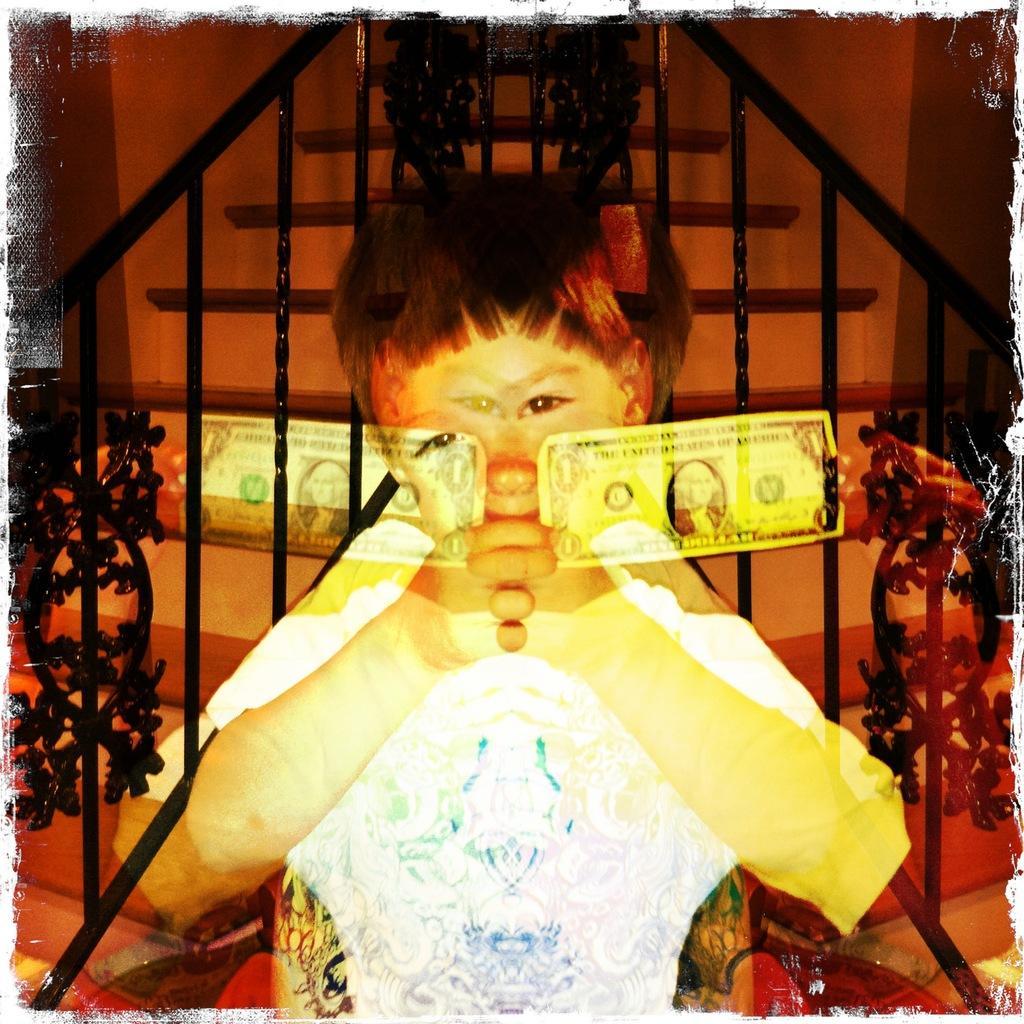Please provide a concise description of this image. In this image I can see image of a boy and I can see a staircase and rods and fence visible in the middle and I can see the wall at the top 